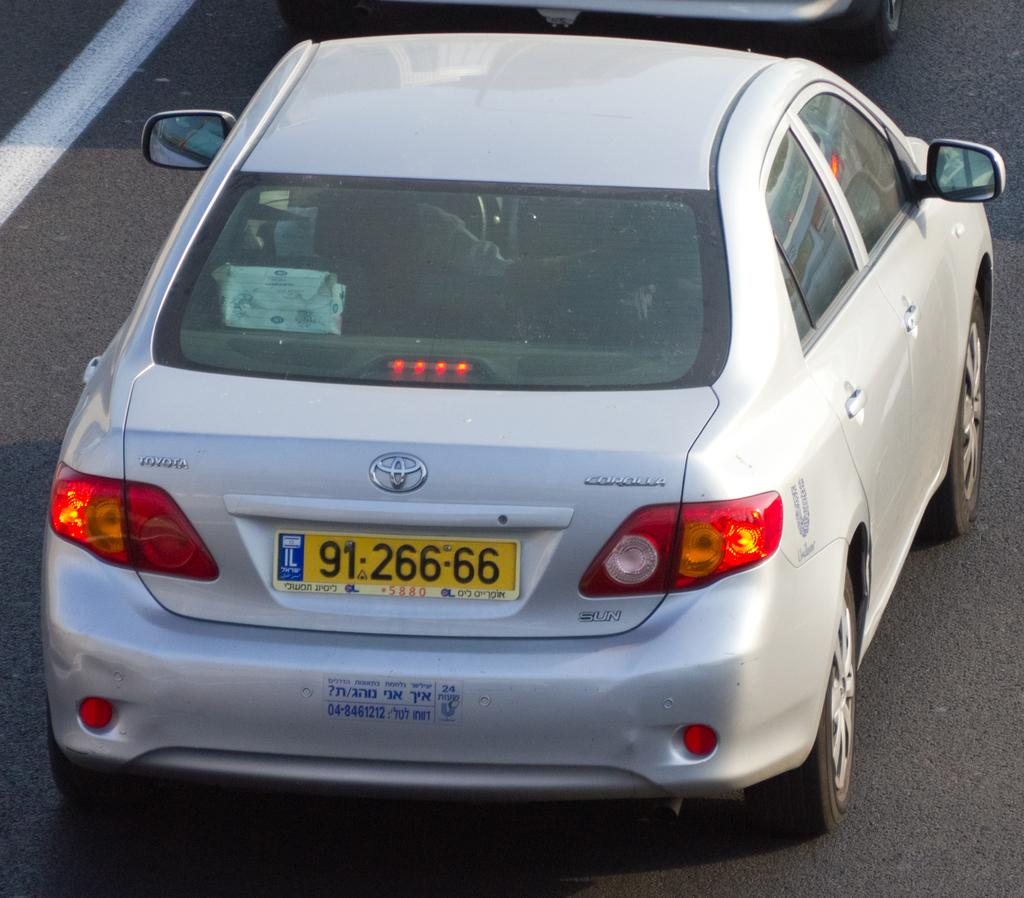<image>
Share a concise interpretation of the image provided. A silver Toyota Corolla has a license plate number 9126666. 